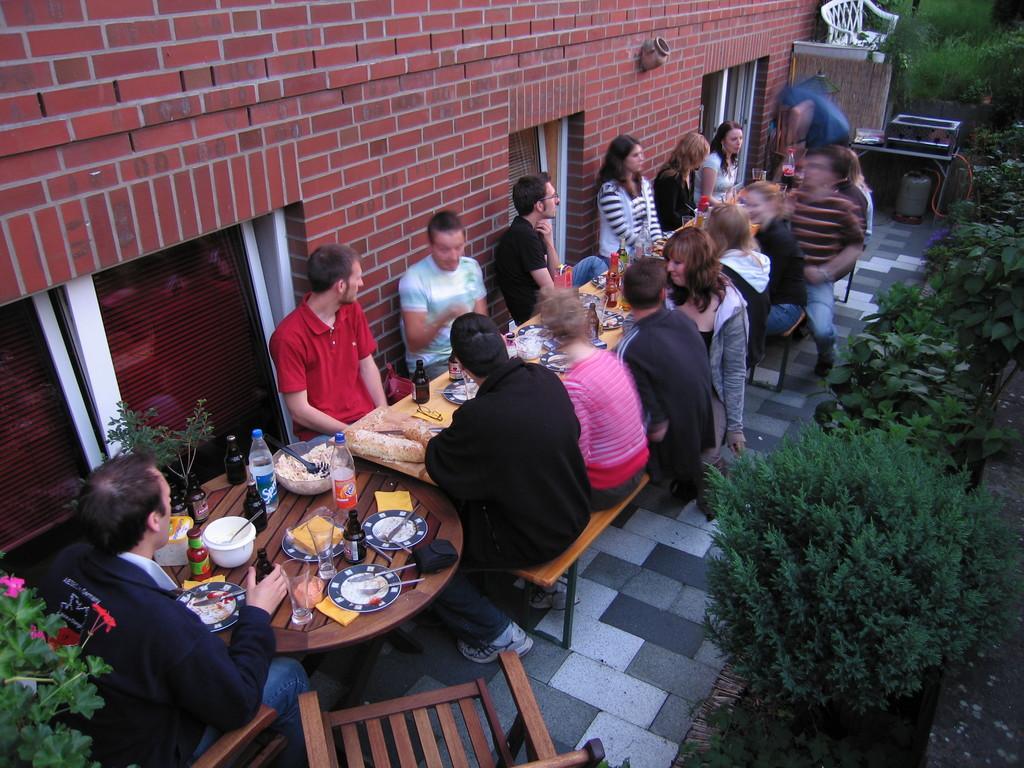How would you summarize this image in a sentence or two? This picture seems to be of inside. On the right we can see the plants and in the center there are group of persons sitting on the benches and there is a table on the top of which food items, plates bottles are placed. In the background we can see the wall which is in red color and a machine placed on the top of the table. 